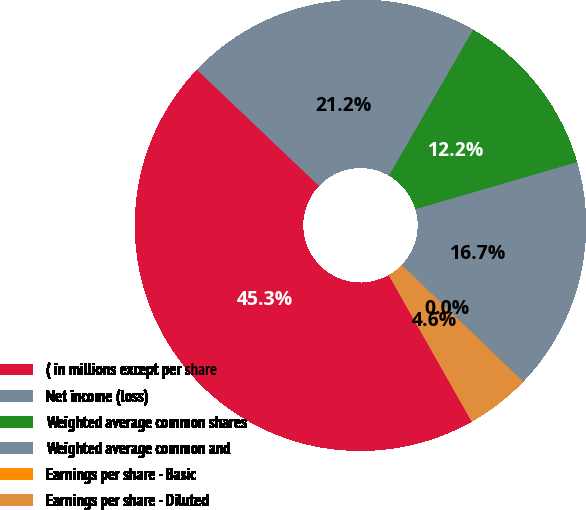Convert chart to OTSL. <chart><loc_0><loc_0><loc_500><loc_500><pie_chart><fcel>( in millions except per share<fcel>Net income (loss)<fcel>Weighted average common shares<fcel>Weighted average common and<fcel>Earnings per share - Basic<fcel>Earnings per share - Diluted<nl><fcel>45.31%<fcel>21.22%<fcel>12.17%<fcel>16.7%<fcel>0.04%<fcel>4.56%<nl></chart> 